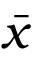<formula> <loc_0><loc_0><loc_500><loc_500>\bar { x }</formula> 